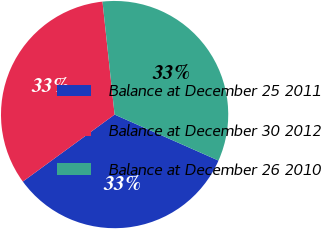Convert chart to OTSL. <chart><loc_0><loc_0><loc_500><loc_500><pie_chart><fcel>Balance at December 25 2011<fcel>Balance at December 30 2012<fcel>Balance at December 26 2010<nl><fcel>33.33%<fcel>33.33%<fcel>33.33%<nl></chart> 